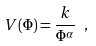Convert formula to latex. <formula><loc_0><loc_0><loc_500><loc_500>V ( \Phi ) = \frac { k } { \Phi ^ { \alpha } } \ ,</formula> 